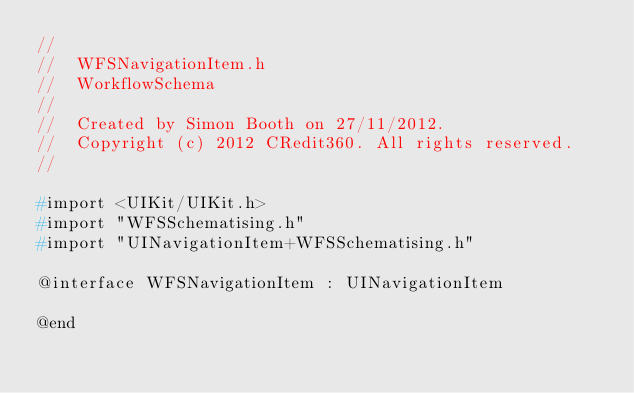<code> <loc_0><loc_0><loc_500><loc_500><_C_>//
//  WFSNavigationItem.h
//  WorkflowSchema
//
//  Created by Simon Booth on 27/11/2012.
//  Copyright (c) 2012 CRedit360. All rights reserved.
//

#import <UIKit/UIKit.h>
#import "WFSSchematising.h"
#import "UINavigationItem+WFSSchematising.h"

@interface WFSNavigationItem : UINavigationItem

@end
</code> 